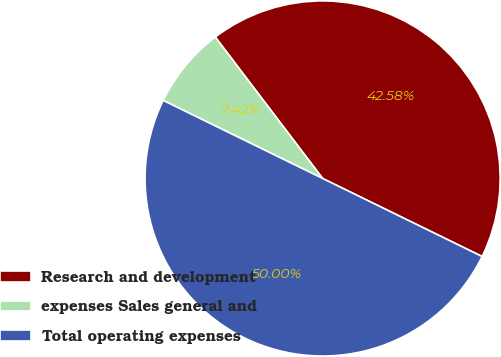Convert chart to OTSL. <chart><loc_0><loc_0><loc_500><loc_500><pie_chart><fcel>Research and development<fcel>expenses Sales general and<fcel>Total operating expenses<nl><fcel>42.58%<fcel>7.42%<fcel>50.0%<nl></chart> 